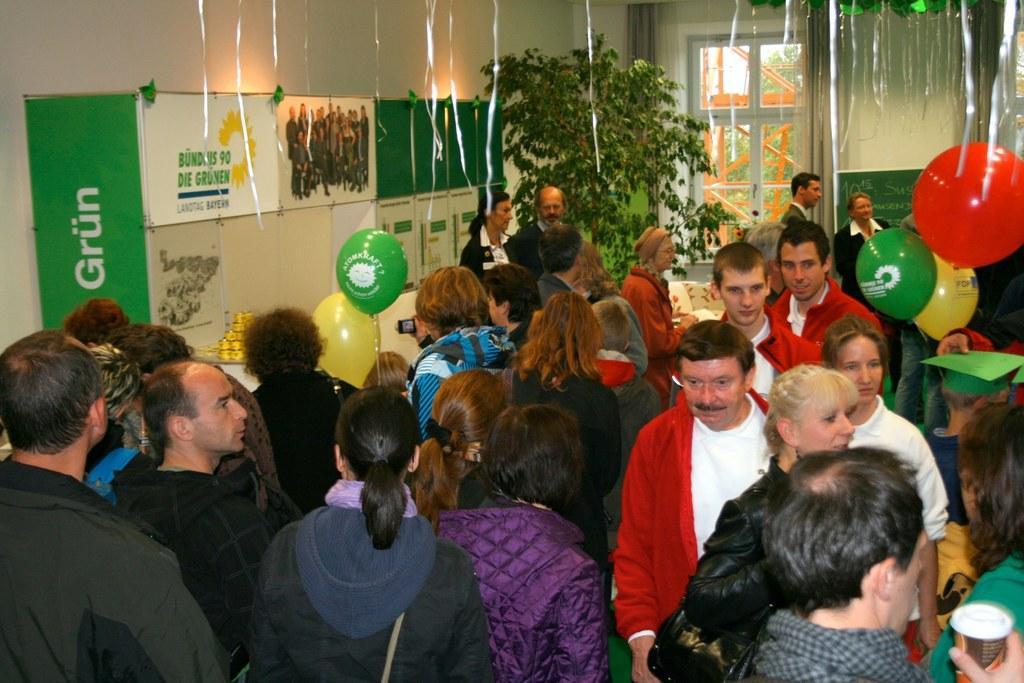How would you summarize this image in a sentence or two? In this image there are group of persons standing and there are balloons. On the left side there are banners with some text written on it and there is a plant. In the background there is a window, outside of the window there is a tree. 